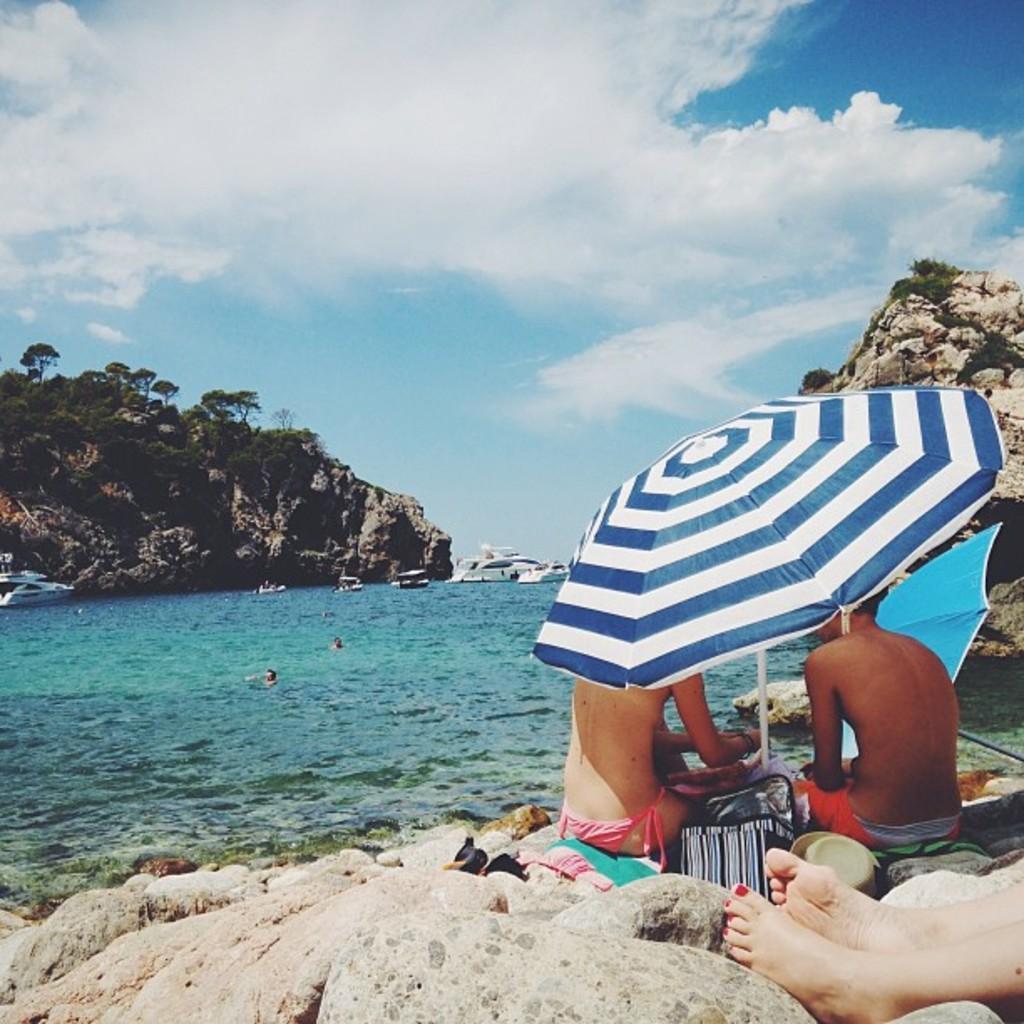Describe this image in one or two sentences. There are two persons sitting on the clothes. Here we can see legs of a person. There are rocks, bag, hat, umbrellas, water, ships, trees, and few persons. In the background there is sky with clouds. 